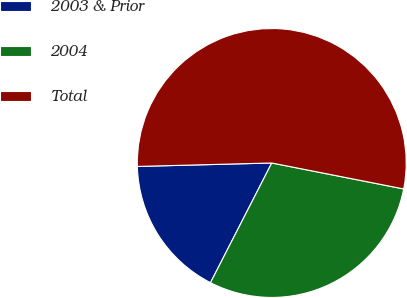Convert chart to OTSL. <chart><loc_0><loc_0><loc_500><loc_500><pie_chart><fcel>2003 & Prior<fcel>2004<fcel>Total<nl><fcel>17.06%<fcel>29.44%<fcel>53.5%<nl></chart> 